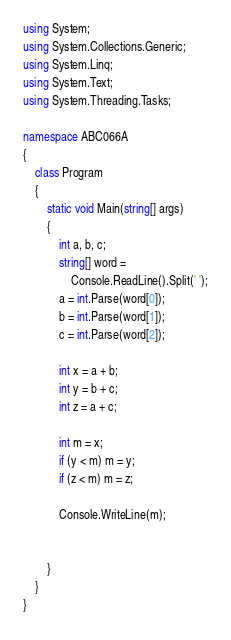Convert code to text. <code><loc_0><loc_0><loc_500><loc_500><_C#_>using System;
using System.Collections.Generic;
using System.Linq;
using System.Text;
using System.Threading.Tasks;

namespace ABC066A
{
    class Program
    {
        static void Main(string[] args)
        {
            int a, b, c;
            string[] word =
                Console.ReadLine().Split(' ');
            a = int.Parse(word[0]);
            b = int.Parse(word[1]);
            c = int.Parse(word[2]);

            int x = a + b;
            int y = b + c;
            int z = a + c;

            int m = x;
            if (y < m) m = y;
            if (z < m) m = z;

            Console.WriteLine(m);


        }
    }
}
</code> 